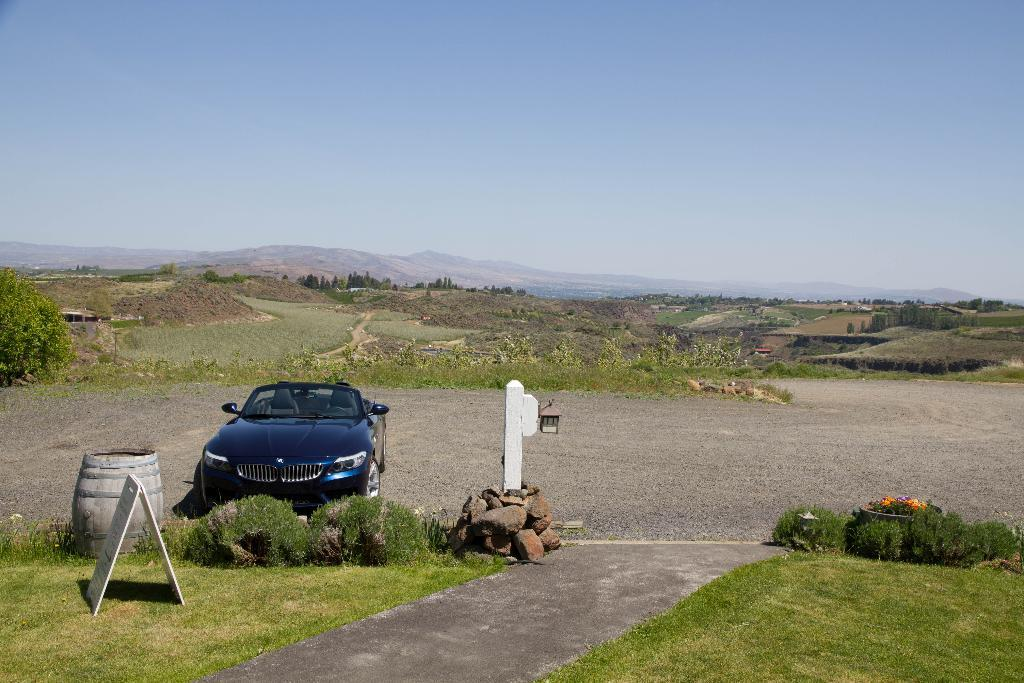What type of vehicle is on the ground in the image? There is a car on the ground in the image. What objects are placed near the car? There are stones, a wooden stick, and a light in the image. What other objects can be seen in the image? There is a board and a barrel in the image. What type of vegetation is present in the image? Grass is present in the image. What type of natural features are visible in the image? Trees and mountains are visible in the image. What part of the natural environment is visible in the image? The sky is visible in the image. What type of actor is visible in the image? There is no actor present in the image. What type of respect can be seen in the image? Respect is not a tangible object or feature that can be seen in the image. 